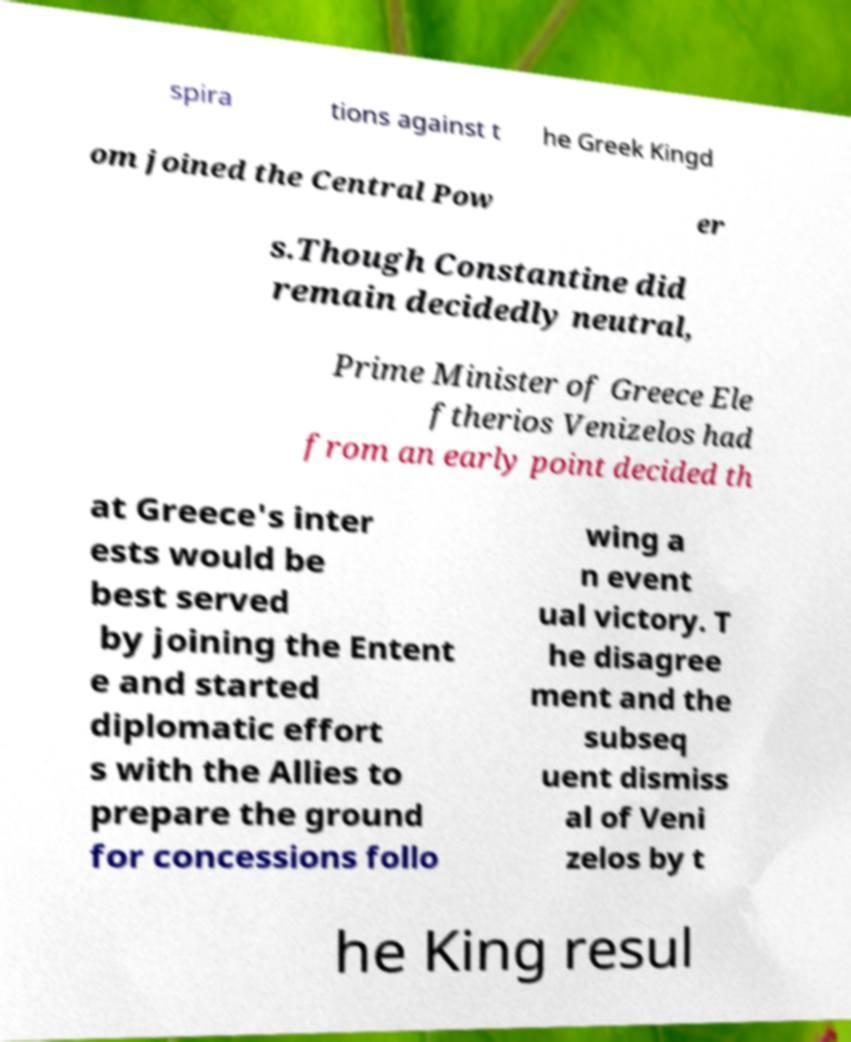Can you read and provide the text displayed in the image?This photo seems to have some interesting text. Can you extract and type it out for me? spira tions against t he Greek Kingd om joined the Central Pow er s.Though Constantine did remain decidedly neutral, Prime Minister of Greece Ele ftherios Venizelos had from an early point decided th at Greece's inter ests would be best served by joining the Entent e and started diplomatic effort s with the Allies to prepare the ground for concessions follo wing a n event ual victory. T he disagree ment and the subseq uent dismiss al of Veni zelos by t he King resul 